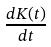Convert formula to latex. <formula><loc_0><loc_0><loc_500><loc_500>\frac { d K ( t ) } { d t }</formula> 